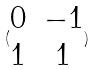Convert formula to latex. <formula><loc_0><loc_0><loc_500><loc_500>( \begin{matrix} 0 & - 1 \\ 1 & 1 \end{matrix} )</formula> 